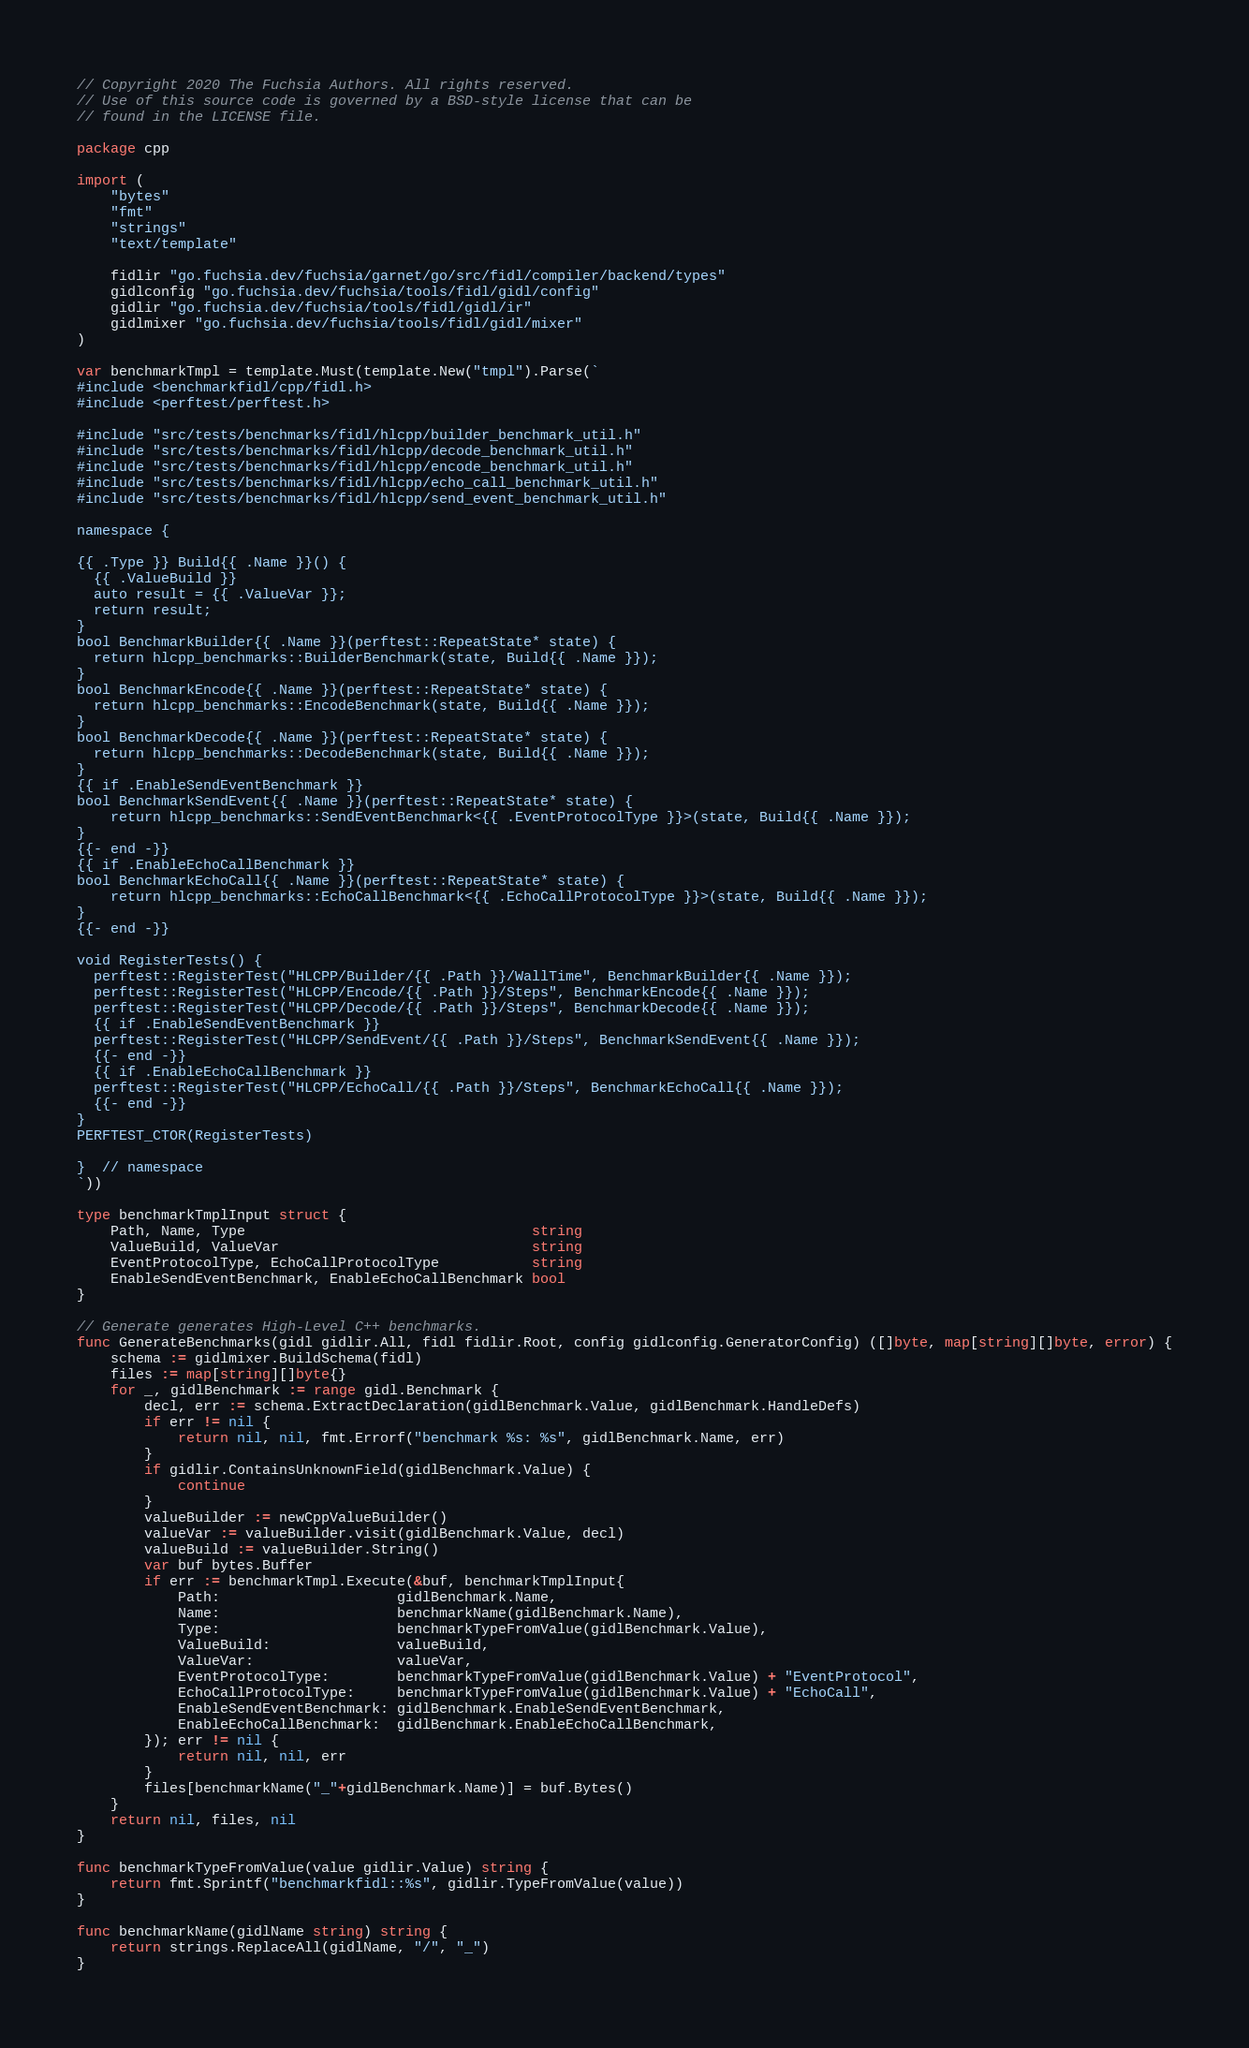<code> <loc_0><loc_0><loc_500><loc_500><_Go_>// Copyright 2020 The Fuchsia Authors. All rights reserved.
// Use of this source code is governed by a BSD-style license that can be
// found in the LICENSE file.

package cpp

import (
	"bytes"
	"fmt"
	"strings"
	"text/template"

	fidlir "go.fuchsia.dev/fuchsia/garnet/go/src/fidl/compiler/backend/types"
	gidlconfig "go.fuchsia.dev/fuchsia/tools/fidl/gidl/config"
	gidlir "go.fuchsia.dev/fuchsia/tools/fidl/gidl/ir"
	gidlmixer "go.fuchsia.dev/fuchsia/tools/fidl/gidl/mixer"
)

var benchmarkTmpl = template.Must(template.New("tmpl").Parse(`
#include <benchmarkfidl/cpp/fidl.h>
#include <perftest/perftest.h>

#include "src/tests/benchmarks/fidl/hlcpp/builder_benchmark_util.h"
#include "src/tests/benchmarks/fidl/hlcpp/decode_benchmark_util.h"
#include "src/tests/benchmarks/fidl/hlcpp/encode_benchmark_util.h"
#include "src/tests/benchmarks/fidl/hlcpp/echo_call_benchmark_util.h"
#include "src/tests/benchmarks/fidl/hlcpp/send_event_benchmark_util.h"

namespace {

{{ .Type }} Build{{ .Name }}() {
  {{ .ValueBuild }}
  auto result = {{ .ValueVar }};
  return result;
}
bool BenchmarkBuilder{{ .Name }}(perftest::RepeatState* state) {
  return hlcpp_benchmarks::BuilderBenchmark(state, Build{{ .Name }});
}
bool BenchmarkEncode{{ .Name }}(perftest::RepeatState* state) {
  return hlcpp_benchmarks::EncodeBenchmark(state, Build{{ .Name }});
}
bool BenchmarkDecode{{ .Name }}(perftest::RepeatState* state) {
  return hlcpp_benchmarks::DecodeBenchmark(state, Build{{ .Name }});
}
{{ if .EnableSendEventBenchmark }}
bool BenchmarkSendEvent{{ .Name }}(perftest::RepeatState* state) {
	return hlcpp_benchmarks::SendEventBenchmark<{{ .EventProtocolType }}>(state, Build{{ .Name }});
}
{{- end -}}
{{ if .EnableEchoCallBenchmark }}
bool BenchmarkEchoCall{{ .Name }}(perftest::RepeatState* state) {
	return hlcpp_benchmarks::EchoCallBenchmark<{{ .EchoCallProtocolType }}>(state, Build{{ .Name }});
}
{{- end -}}

void RegisterTests() {
  perftest::RegisterTest("HLCPP/Builder/{{ .Path }}/WallTime", BenchmarkBuilder{{ .Name }});
  perftest::RegisterTest("HLCPP/Encode/{{ .Path }}/Steps", BenchmarkEncode{{ .Name }});
  perftest::RegisterTest("HLCPP/Decode/{{ .Path }}/Steps", BenchmarkDecode{{ .Name }});
  {{ if .EnableSendEventBenchmark }}
  perftest::RegisterTest("HLCPP/SendEvent/{{ .Path }}/Steps", BenchmarkSendEvent{{ .Name }});
  {{- end -}}
  {{ if .EnableEchoCallBenchmark }}
  perftest::RegisterTest("HLCPP/EchoCall/{{ .Path }}/Steps", BenchmarkEchoCall{{ .Name }});
  {{- end -}}
}
PERFTEST_CTOR(RegisterTests)

}  // namespace
`))

type benchmarkTmplInput struct {
	Path, Name, Type                                  string
	ValueBuild, ValueVar                              string
	EventProtocolType, EchoCallProtocolType           string
	EnableSendEventBenchmark, EnableEchoCallBenchmark bool
}

// Generate generates High-Level C++ benchmarks.
func GenerateBenchmarks(gidl gidlir.All, fidl fidlir.Root, config gidlconfig.GeneratorConfig) ([]byte, map[string][]byte, error) {
	schema := gidlmixer.BuildSchema(fidl)
	files := map[string][]byte{}
	for _, gidlBenchmark := range gidl.Benchmark {
		decl, err := schema.ExtractDeclaration(gidlBenchmark.Value, gidlBenchmark.HandleDefs)
		if err != nil {
			return nil, nil, fmt.Errorf("benchmark %s: %s", gidlBenchmark.Name, err)
		}
		if gidlir.ContainsUnknownField(gidlBenchmark.Value) {
			continue
		}
		valueBuilder := newCppValueBuilder()
		valueVar := valueBuilder.visit(gidlBenchmark.Value, decl)
		valueBuild := valueBuilder.String()
		var buf bytes.Buffer
		if err := benchmarkTmpl.Execute(&buf, benchmarkTmplInput{
			Path:                     gidlBenchmark.Name,
			Name:                     benchmarkName(gidlBenchmark.Name),
			Type:                     benchmarkTypeFromValue(gidlBenchmark.Value),
			ValueBuild:               valueBuild,
			ValueVar:                 valueVar,
			EventProtocolType:        benchmarkTypeFromValue(gidlBenchmark.Value) + "EventProtocol",
			EchoCallProtocolType:     benchmarkTypeFromValue(gidlBenchmark.Value) + "EchoCall",
			EnableSendEventBenchmark: gidlBenchmark.EnableSendEventBenchmark,
			EnableEchoCallBenchmark:  gidlBenchmark.EnableEchoCallBenchmark,
		}); err != nil {
			return nil, nil, err
		}
		files[benchmarkName("_"+gidlBenchmark.Name)] = buf.Bytes()
	}
	return nil, files, nil
}

func benchmarkTypeFromValue(value gidlir.Value) string {
	return fmt.Sprintf("benchmarkfidl::%s", gidlir.TypeFromValue(value))
}

func benchmarkName(gidlName string) string {
	return strings.ReplaceAll(gidlName, "/", "_")
}
</code> 